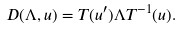<formula> <loc_0><loc_0><loc_500><loc_500>D ( \Lambda , u ) = T ( u ^ { \prime } ) \Lambda T ^ { - 1 } ( u ) .</formula> 